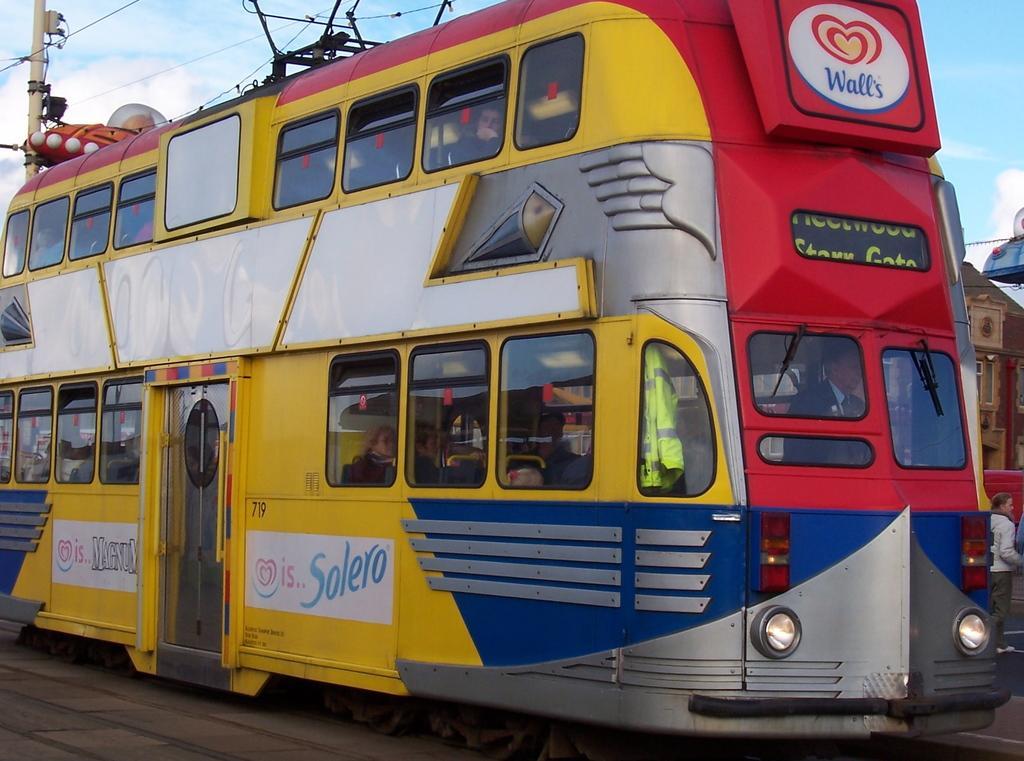Could you give a brief overview of what you see in this image? In this picture we can see many peoples were sitting inside the bus. At the top we can see electric wires. In the top left corner there is an electric pole. In the top right corner we can see sky and clouds. On the right there is a woman who is standing near to the building. 